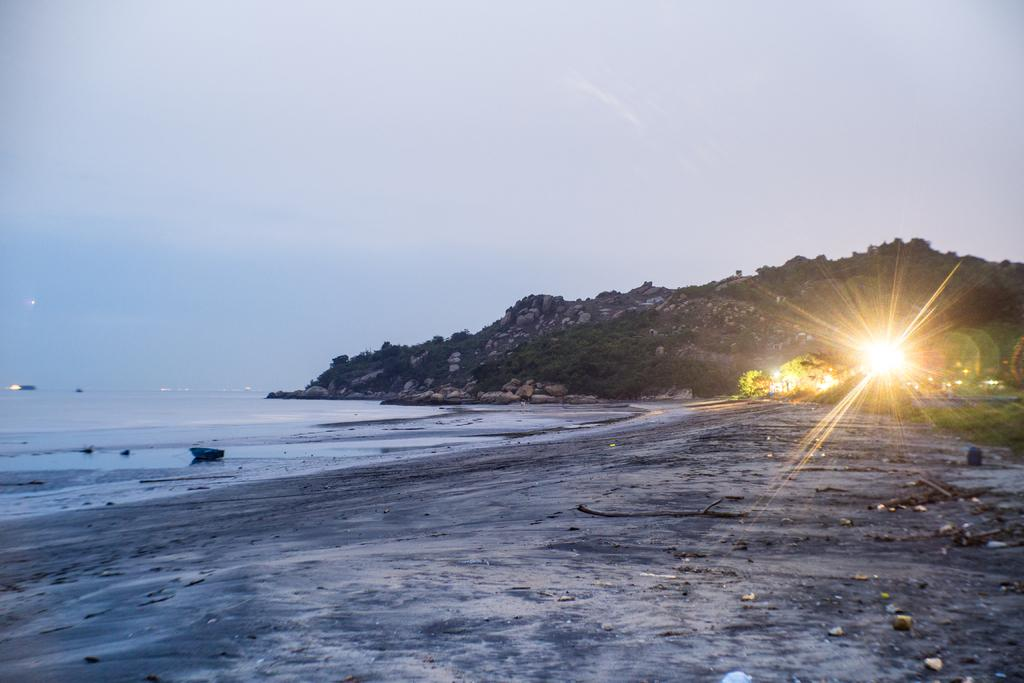What type of vegetation can be seen in the image? There are trees in the image. What geographical feature is present in the image? There is a mountain in the image. What is the source of light visible in the image? The source of light visible in the image is not specified, but it could be sunlight or artificial light. What natural element is visible in the image? There is water visible in the image. What is the color of the sky in the image? The sky is blue and white in color. Can you tell me how many beggars are visible in the image? There are no beggars present in the image. What type of play is being performed in the image? There is no play being performed in the image. Where is the faucet located in the image? There is no faucet present in the image. 